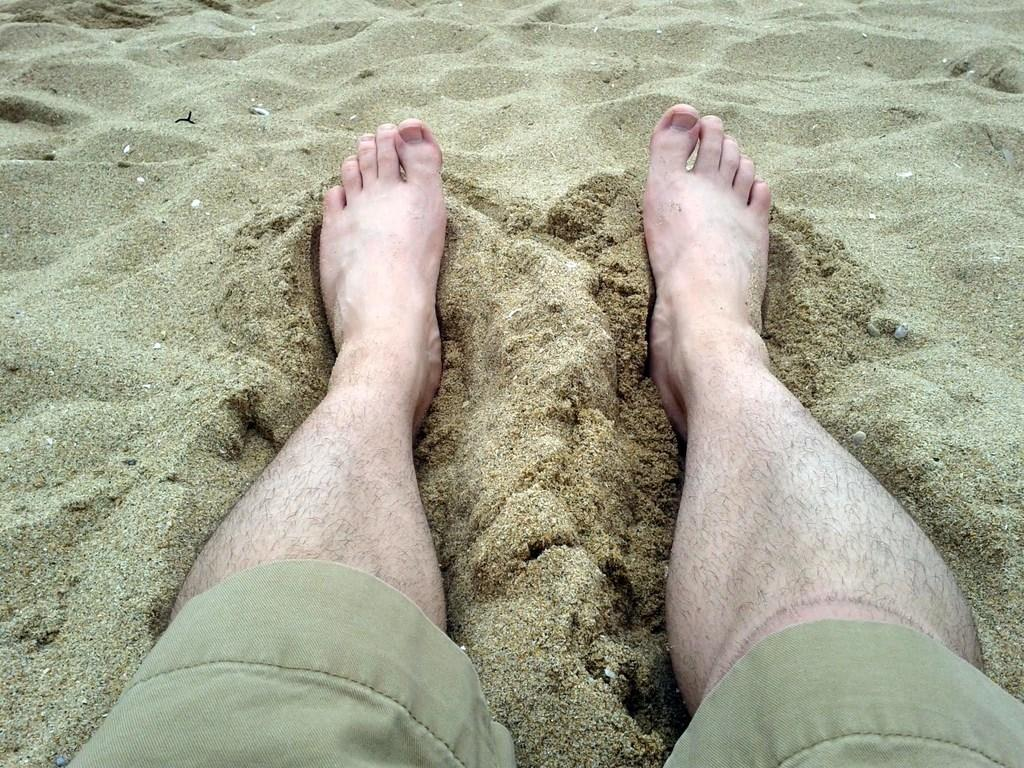What can be seen in the sand in the image? There are two legs in the sand in the image. What type of corn can be seen growing near the legs in the image? There is no corn present in the image; it only features two legs in the sand. 